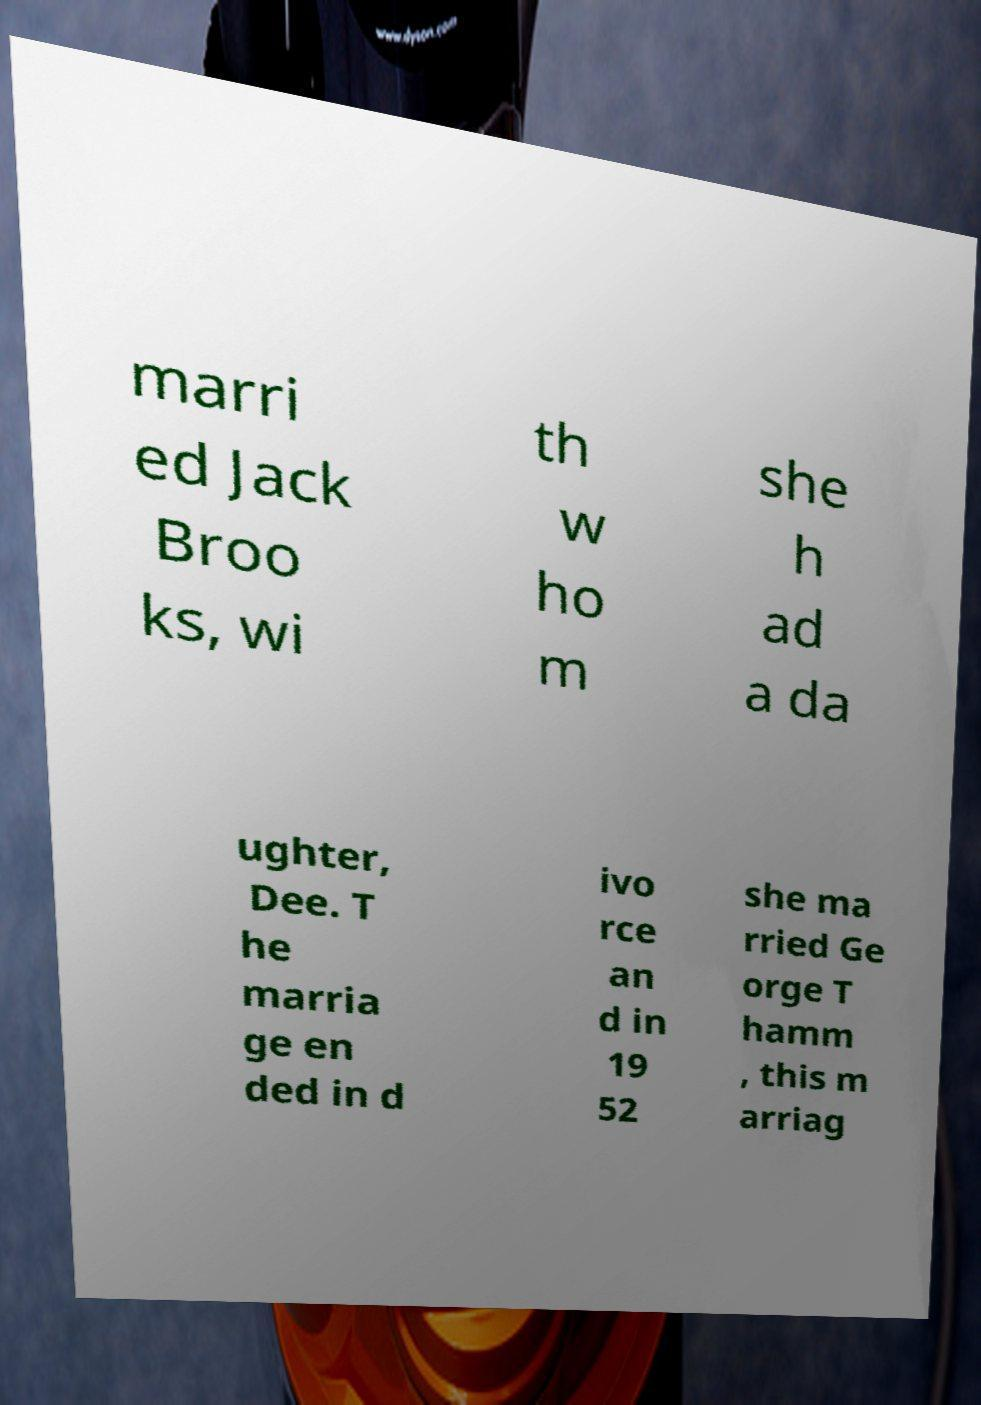What messages or text are displayed in this image? I need them in a readable, typed format. marri ed Jack Broo ks, wi th w ho m she h ad a da ughter, Dee. T he marria ge en ded in d ivo rce an d in 19 52 she ma rried Ge orge T hamm , this m arriag 